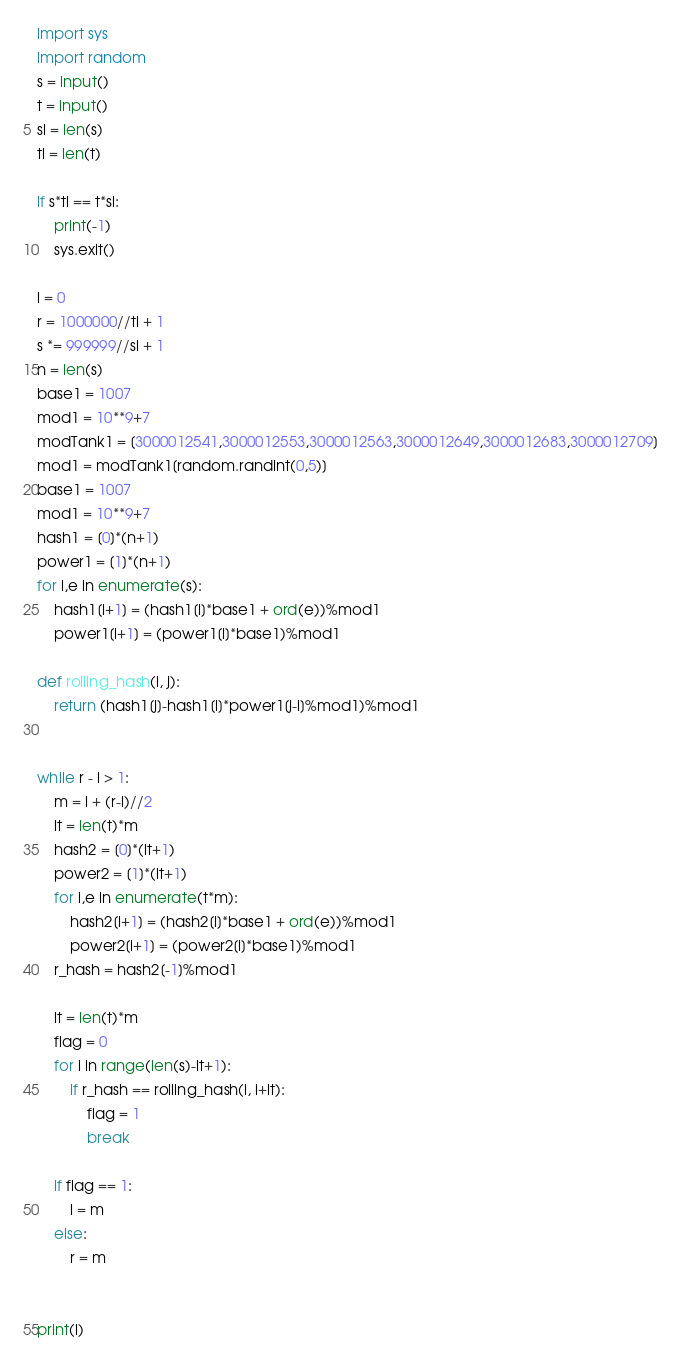<code> <loc_0><loc_0><loc_500><loc_500><_Python_>import sys
import random
s = input()
t = input()
sl = len(s)
tl = len(t)

if s*tl == t*sl:
    print(-1)
    sys.exit()
    
l = 0
r = 1000000//tl + 1
s *= 999999//sl + 1
n = len(s)
base1 = 1007
mod1 = 10**9+7
modTank1 = [3000012541,3000012553,3000012563,3000012649,3000012683,3000012709]
mod1 = modTank1[random.randint(0,5)]
base1 = 1007
mod1 = 10**9+7
hash1 = [0]*(n+1)
power1 = [1]*(n+1)
for i,e in enumerate(s):
    hash1[i+1] = (hash1[i]*base1 + ord(e))%mod1
    power1[i+1] = (power1[i]*base1)%mod1

def rolling_hash(i, j):
    return (hash1[j]-hash1[i]*power1[j-i]%mod1)%mod1


while r - l > 1:
    m = l + (r-l)//2
    lt = len(t)*m
    hash2 = [0]*(lt+1)
    power2 = [1]*(lt+1)
    for i,e in enumerate(t*m):
        hash2[i+1] = (hash2[i]*base1 + ord(e))%mod1
        power2[i+1] = (power2[i]*base1)%mod1
    r_hash = hash2[-1]%mod1

    lt = len(t)*m
    flag = 0
    for i in range(len(s)-lt+1):
        if r_hash == rolling_hash(i, i+lt):
            flag = 1
            break

    if flag == 1:
        l = m
    else:
        r = m


print(l)
</code> 